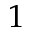<formula> <loc_0><loc_0><loc_500><loc_500>1</formula> 